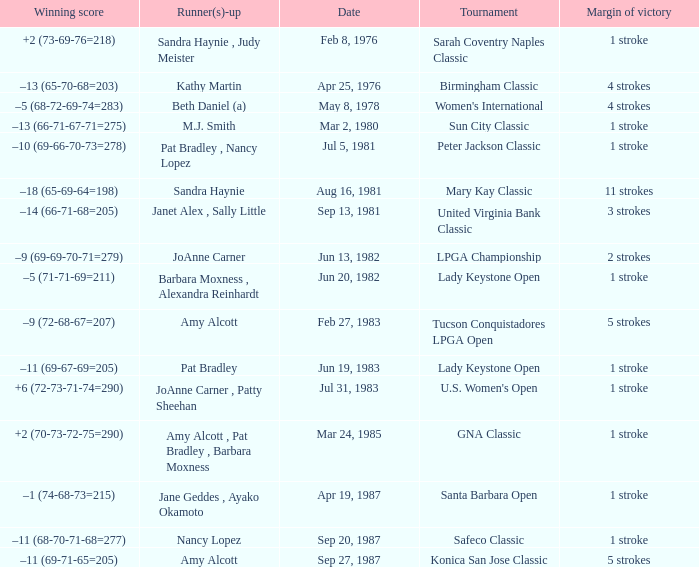Can you parse all the data within this table? {'header': ['Winning score', 'Runner(s)-up', 'Date', 'Tournament', 'Margin of victory'], 'rows': [['+2 (73-69-76=218)', 'Sandra Haynie , Judy Meister', 'Feb 8, 1976', 'Sarah Coventry Naples Classic', '1 stroke'], ['–13 (65-70-68=203)', 'Kathy Martin', 'Apr 25, 1976', 'Birmingham Classic', '4 strokes'], ['–5 (68-72-69-74=283)', 'Beth Daniel (a)', 'May 8, 1978', "Women's International", '4 strokes'], ['–13 (66-71-67-71=275)', 'M.J. Smith', 'Mar 2, 1980', 'Sun City Classic', '1 stroke'], ['–10 (69-66-70-73=278)', 'Pat Bradley , Nancy Lopez', 'Jul 5, 1981', 'Peter Jackson Classic', '1 stroke'], ['–18 (65-69-64=198)', 'Sandra Haynie', 'Aug 16, 1981', 'Mary Kay Classic', '11 strokes'], ['–14 (66-71-68=205)', 'Janet Alex , Sally Little', 'Sep 13, 1981', 'United Virginia Bank Classic', '3 strokes'], ['–9 (69-69-70-71=279)', 'JoAnne Carner', 'Jun 13, 1982', 'LPGA Championship', '2 strokes'], ['–5 (71-71-69=211)', 'Barbara Moxness , Alexandra Reinhardt', 'Jun 20, 1982', 'Lady Keystone Open', '1 stroke'], ['–9 (72-68-67=207)', 'Amy Alcott', 'Feb 27, 1983', 'Tucson Conquistadores LPGA Open', '5 strokes'], ['–11 (69-67-69=205)', 'Pat Bradley', 'Jun 19, 1983', 'Lady Keystone Open', '1 stroke'], ['+6 (72-73-71-74=290)', 'JoAnne Carner , Patty Sheehan', 'Jul 31, 1983', "U.S. Women's Open", '1 stroke'], ['+2 (70-73-72-75=290)', 'Amy Alcott , Pat Bradley , Barbara Moxness', 'Mar 24, 1985', 'GNA Classic', '1 stroke'], ['–1 (74-68-73=215)', 'Jane Geddes , Ayako Okamoto', 'Apr 19, 1987', 'Santa Barbara Open', '1 stroke'], ['–11 (68-70-71-68=277)', 'Nancy Lopez', 'Sep 20, 1987', 'Safeco Classic', '1 stroke'], ['–11 (69-71-65=205)', 'Amy Alcott', 'Sep 27, 1987', 'Konica San Jose Classic', '5 strokes']]} What is the margin of victory when the tournament is konica san jose classic? 5 strokes. 